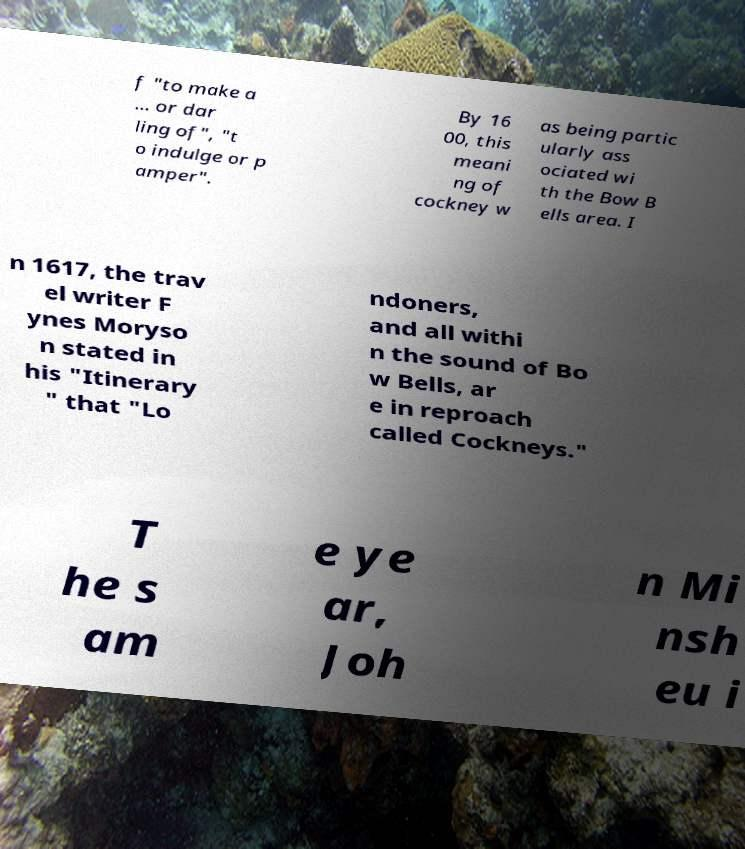Could you assist in decoding the text presented in this image and type it out clearly? f "to make a ... or dar ling of", "t o indulge or p amper". By 16 00, this meani ng of cockney w as being partic ularly ass ociated wi th the Bow B ells area. I n 1617, the trav el writer F ynes Moryso n stated in his "Itinerary " that "Lo ndoners, and all withi n the sound of Bo w Bells, ar e in reproach called Cockneys." T he s am e ye ar, Joh n Mi nsh eu i 